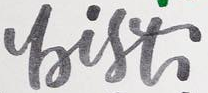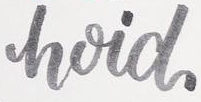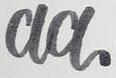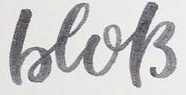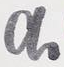What words can you see in these images in sequence, separated by a semicolon? bist; hoid; aa; beols; a 